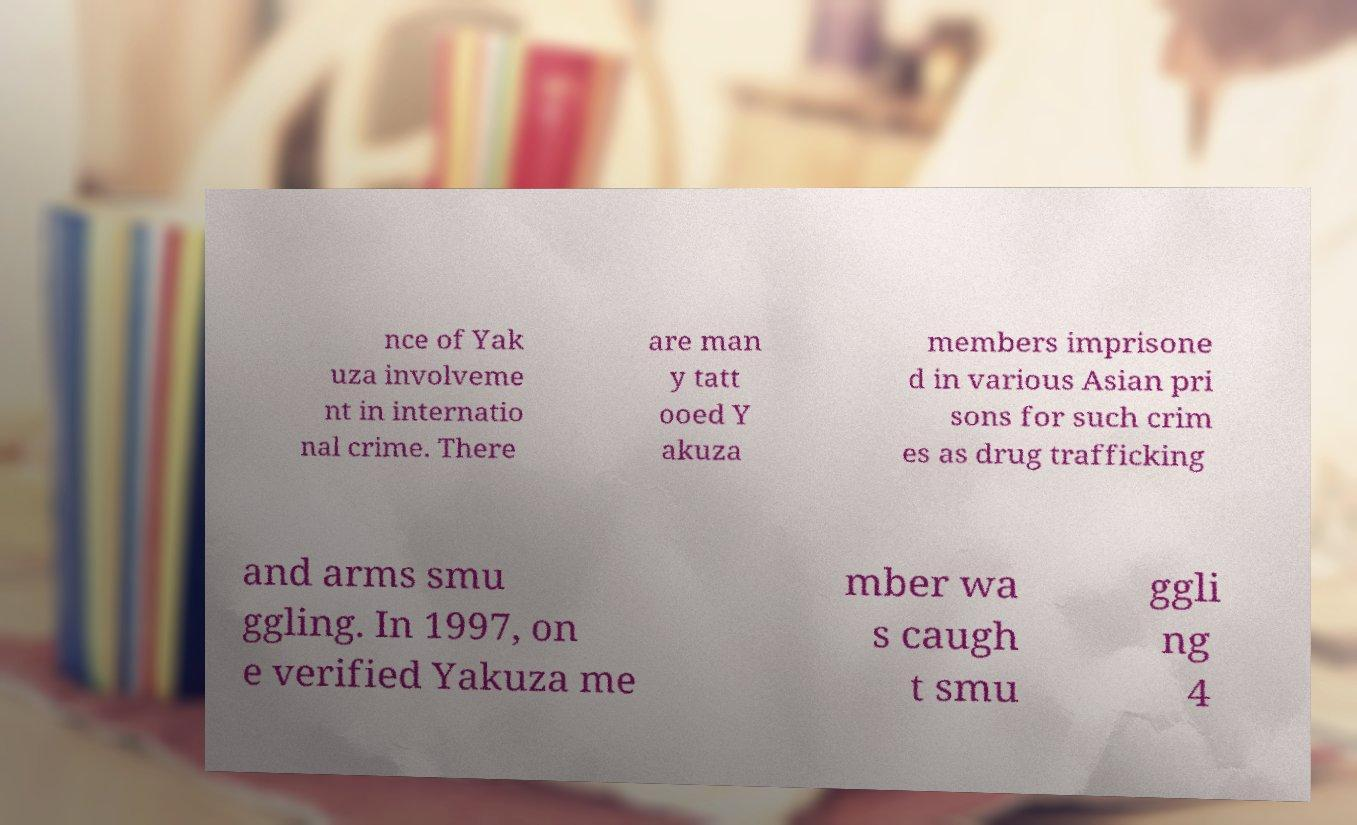Could you extract and type out the text from this image? nce of Yak uza involveme nt in internatio nal crime. There are man y tatt ooed Y akuza members imprisone d in various Asian pri sons for such crim es as drug trafficking and arms smu ggling. In 1997, on e verified Yakuza me mber wa s caugh t smu ggli ng 4 